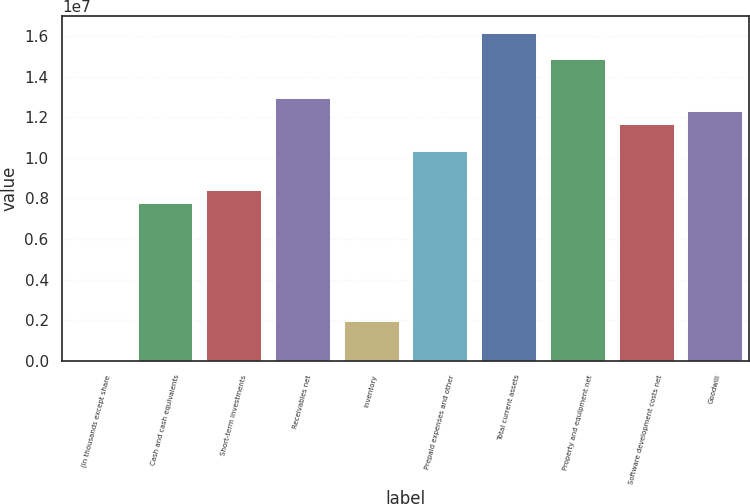Convert chart. <chart><loc_0><loc_0><loc_500><loc_500><bar_chart><fcel>(In thousands except share<fcel>Cash and cash equivalents<fcel>Short-term investments<fcel>Receivables net<fcel>Inventory<fcel>Prepaid expenses and other<fcel>Total current assets<fcel>Property and equipment net<fcel>Software development costs net<fcel>Goodwill<nl><fcel>2017<fcel>7.76277e+06<fcel>8.4095e+06<fcel>1.29366e+07<fcel>1.94221e+06<fcel>1.03497e+07<fcel>1.61703e+07<fcel>1.48768e+07<fcel>1.16431e+07<fcel>1.22899e+07<nl></chart> 